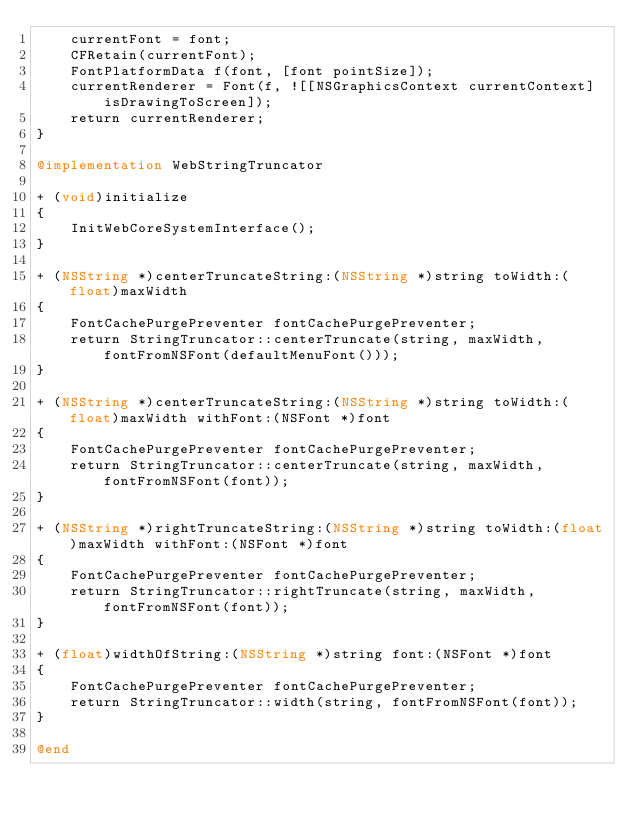Convert code to text. <code><loc_0><loc_0><loc_500><loc_500><_ObjectiveC_>    currentFont = font;
    CFRetain(currentFont);
    FontPlatformData f(font, [font pointSize]);
    currentRenderer = Font(f, ![[NSGraphicsContext currentContext] isDrawingToScreen]);
    return currentRenderer;
}

@implementation WebStringTruncator

+ (void)initialize
{
    InitWebCoreSystemInterface();
}

+ (NSString *)centerTruncateString:(NSString *)string toWidth:(float)maxWidth
{
    FontCachePurgePreventer fontCachePurgePreventer;
    return StringTruncator::centerTruncate(string, maxWidth, fontFromNSFont(defaultMenuFont()));
}

+ (NSString *)centerTruncateString:(NSString *)string toWidth:(float)maxWidth withFont:(NSFont *)font
{
    FontCachePurgePreventer fontCachePurgePreventer;
    return StringTruncator::centerTruncate(string, maxWidth, fontFromNSFont(font));
}

+ (NSString *)rightTruncateString:(NSString *)string toWidth:(float)maxWidth withFont:(NSFont *)font
{
    FontCachePurgePreventer fontCachePurgePreventer;
    return StringTruncator::rightTruncate(string, maxWidth, fontFromNSFont(font));
}

+ (float)widthOfString:(NSString *)string font:(NSFont *)font
{
    FontCachePurgePreventer fontCachePurgePreventer;
    return StringTruncator::width(string, fontFromNSFont(font));
}

@end
</code> 